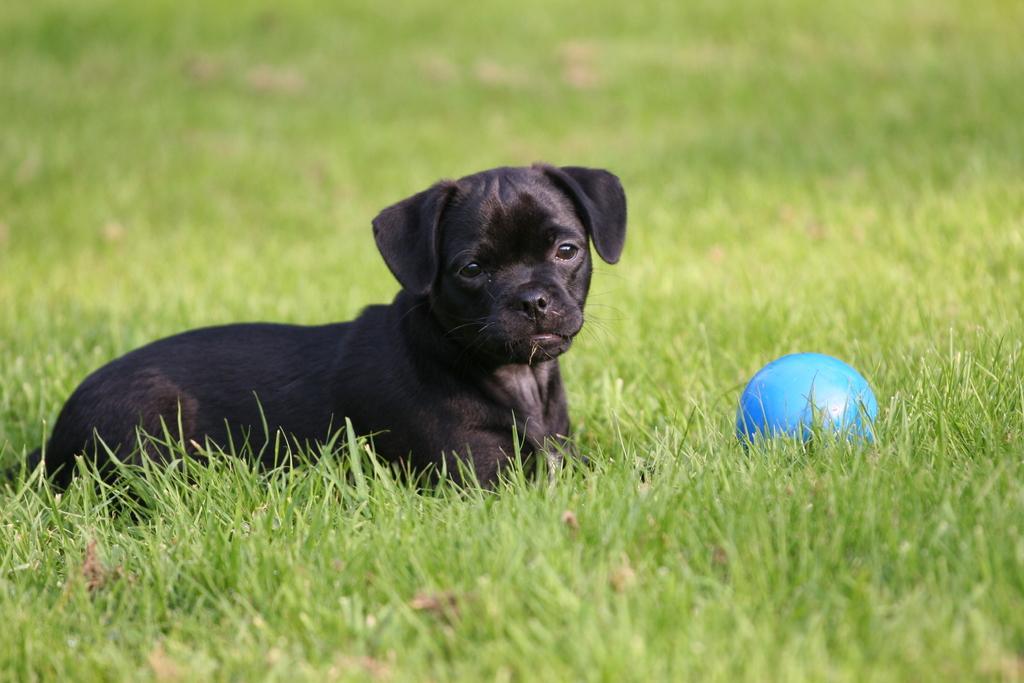Please provide a concise description of this image. In this picture we can see dog and ball on the green grass. In the background of the image it is blurry. 